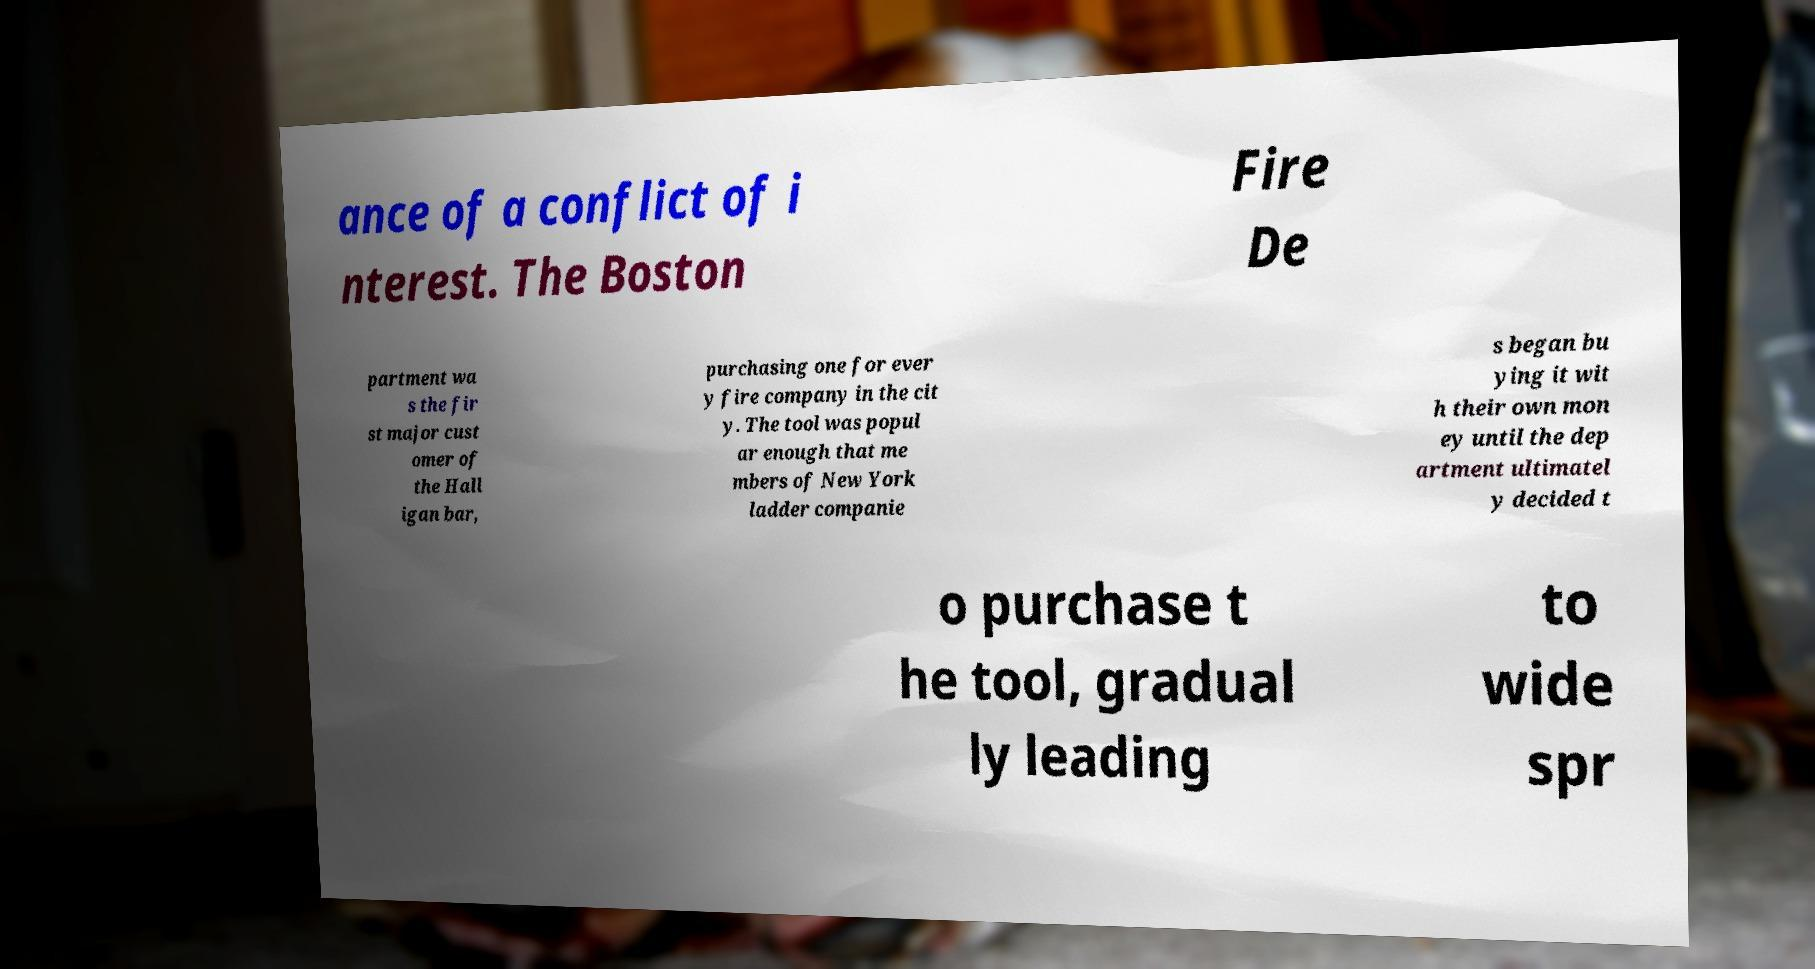I need the written content from this picture converted into text. Can you do that? ance of a conflict of i nterest. The Boston Fire De partment wa s the fir st major cust omer of the Hall igan bar, purchasing one for ever y fire company in the cit y. The tool was popul ar enough that me mbers of New York ladder companie s began bu ying it wit h their own mon ey until the dep artment ultimatel y decided t o purchase t he tool, gradual ly leading to wide spr 